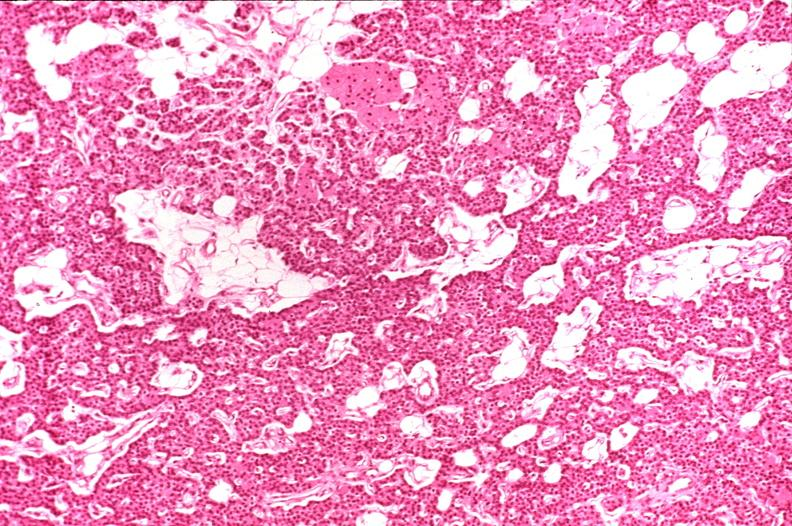s conjoined twins present?
Answer the question using a single word or phrase. No 